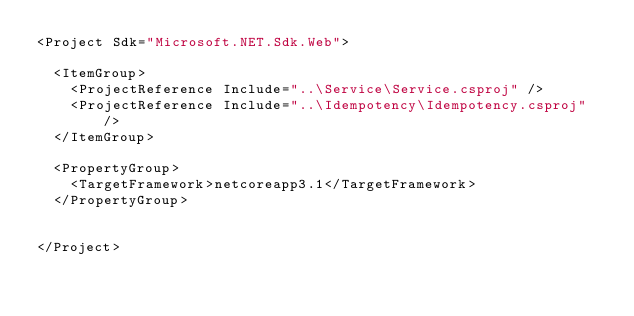Convert code to text. <code><loc_0><loc_0><loc_500><loc_500><_XML_><Project Sdk="Microsoft.NET.Sdk.Web">

  <ItemGroup>
    <ProjectReference Include="..\Service\Service.csproj" />
    <ProjectReference Include="..\Idempotency\Idempotency.csproj" />
  </ItemGroup>

  <PropertyGroup>
    <TargetFramework>netcoreapp3.1</TargetFramework>
  </PropertyGroup>


</Project>
</code> 